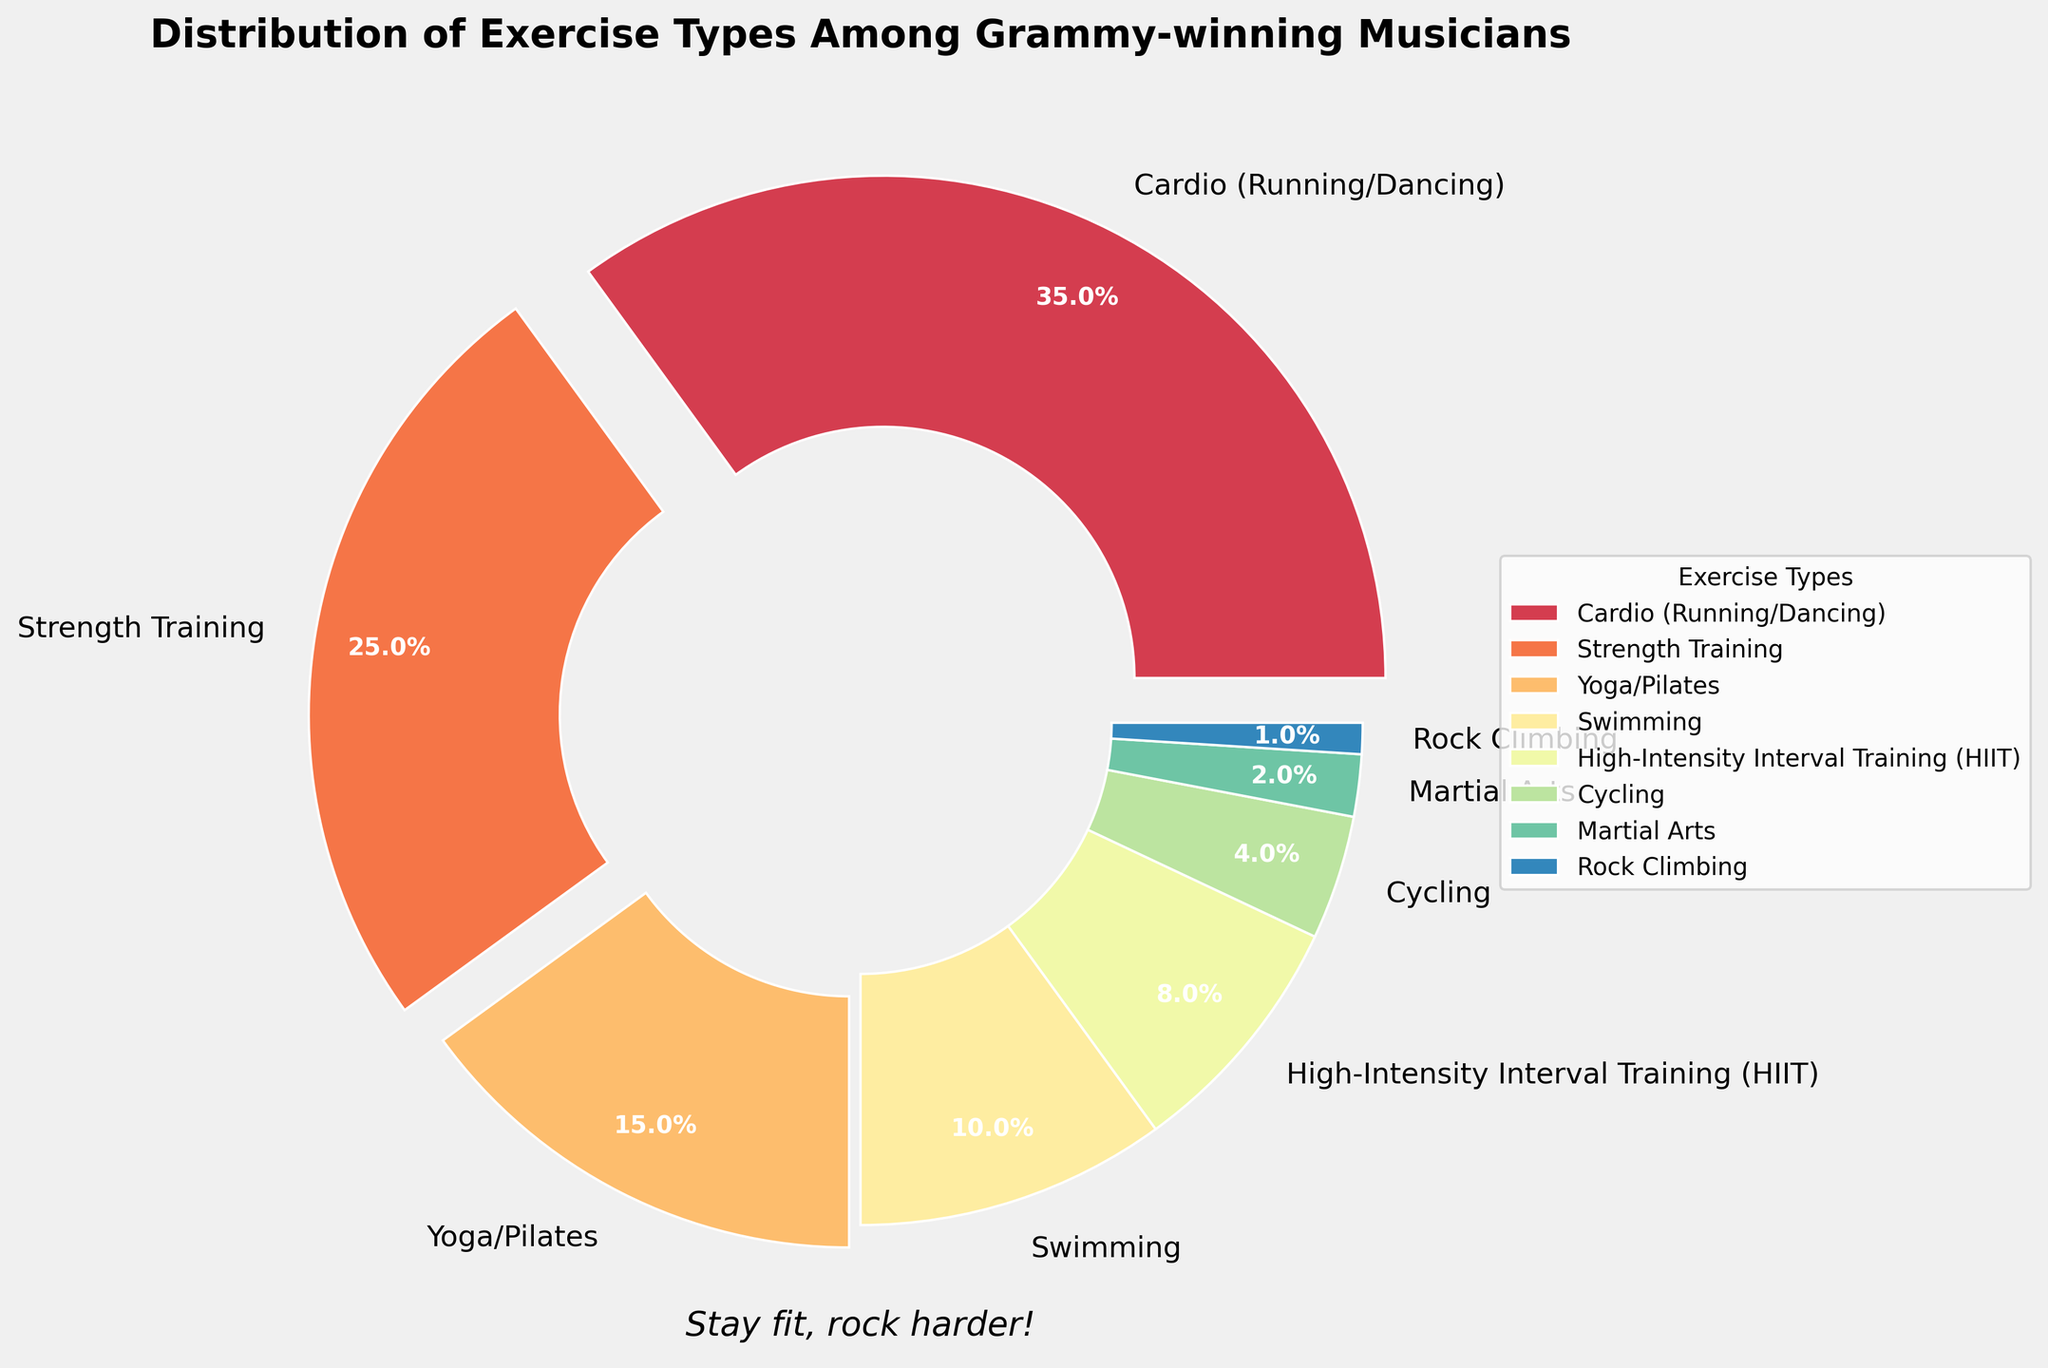Which exercise type is the most popular among Grammy-winning musicians? Cardio (Running/Dancing) has the largest percentage at 35%. This can be observed as the largest portion of the pie chart.
Answer: Cardio (Running/Dancing) Which two exercise types combined make up 50% of the total? Cardio (Running/Dancing) at 35% and Strength Training at 25% together sum up to 60%, which is more than 50%. The next highest segment, Yoga/Pilates, only contributes 15%, making it insufficient to surpass 50% when combined with other smaller segments.
Answer: Cardio (Running/Dancing) and Strength Training What is the least popular exercise type among these musicians? Rock Climbing has the smallest portion of the pie chart at 1%.
Answer: Rock Climbing How does the percentage of musicians who prefer Yoga/Pilates compare with those who prefer Strength Training? Yoga/Pilates has 15% of the musicians, while Strength Training has 25%. This means Strength Training is 10% more popular than Yoga/Pilates.
Answer: Strength Training is 10% more popular What percentage of Grammy-winning musicians engage in cycling? The section for Cycling shows a value of 4% on the pie chart.
Answer: 4% Calculate the total percentage of musicians involved in High-Intensity Interval Training (HIIT), Cycling, Martial Arts, and Rock Climbing. HIIT contributes 8%, Cycling has 4%, Martial Arts offers 2%, and Rock Climbing is 1%. Adding them together: 8% + 4% + 2% + 1% = 15%.
Answer: 15% Compare the percentages of Cardio (Running/Dancing) and Swimming. Which is larger and by how much? Cardio (Running/Dancing) is at 35% and Swimming is at 10%. The difference between them is 35% - 10% = 25%. Therefore, Cardio is larger by 25%.
Answer: Cardio is larger by 25% Which exercise type occupies a portion with a light blue shade in the chart? Based on the given data and typical color mappings in charts, Swimming often uses shades of blue, and particularly in this chart setup, it occupies a light blue shade.
Answer: Swimming 